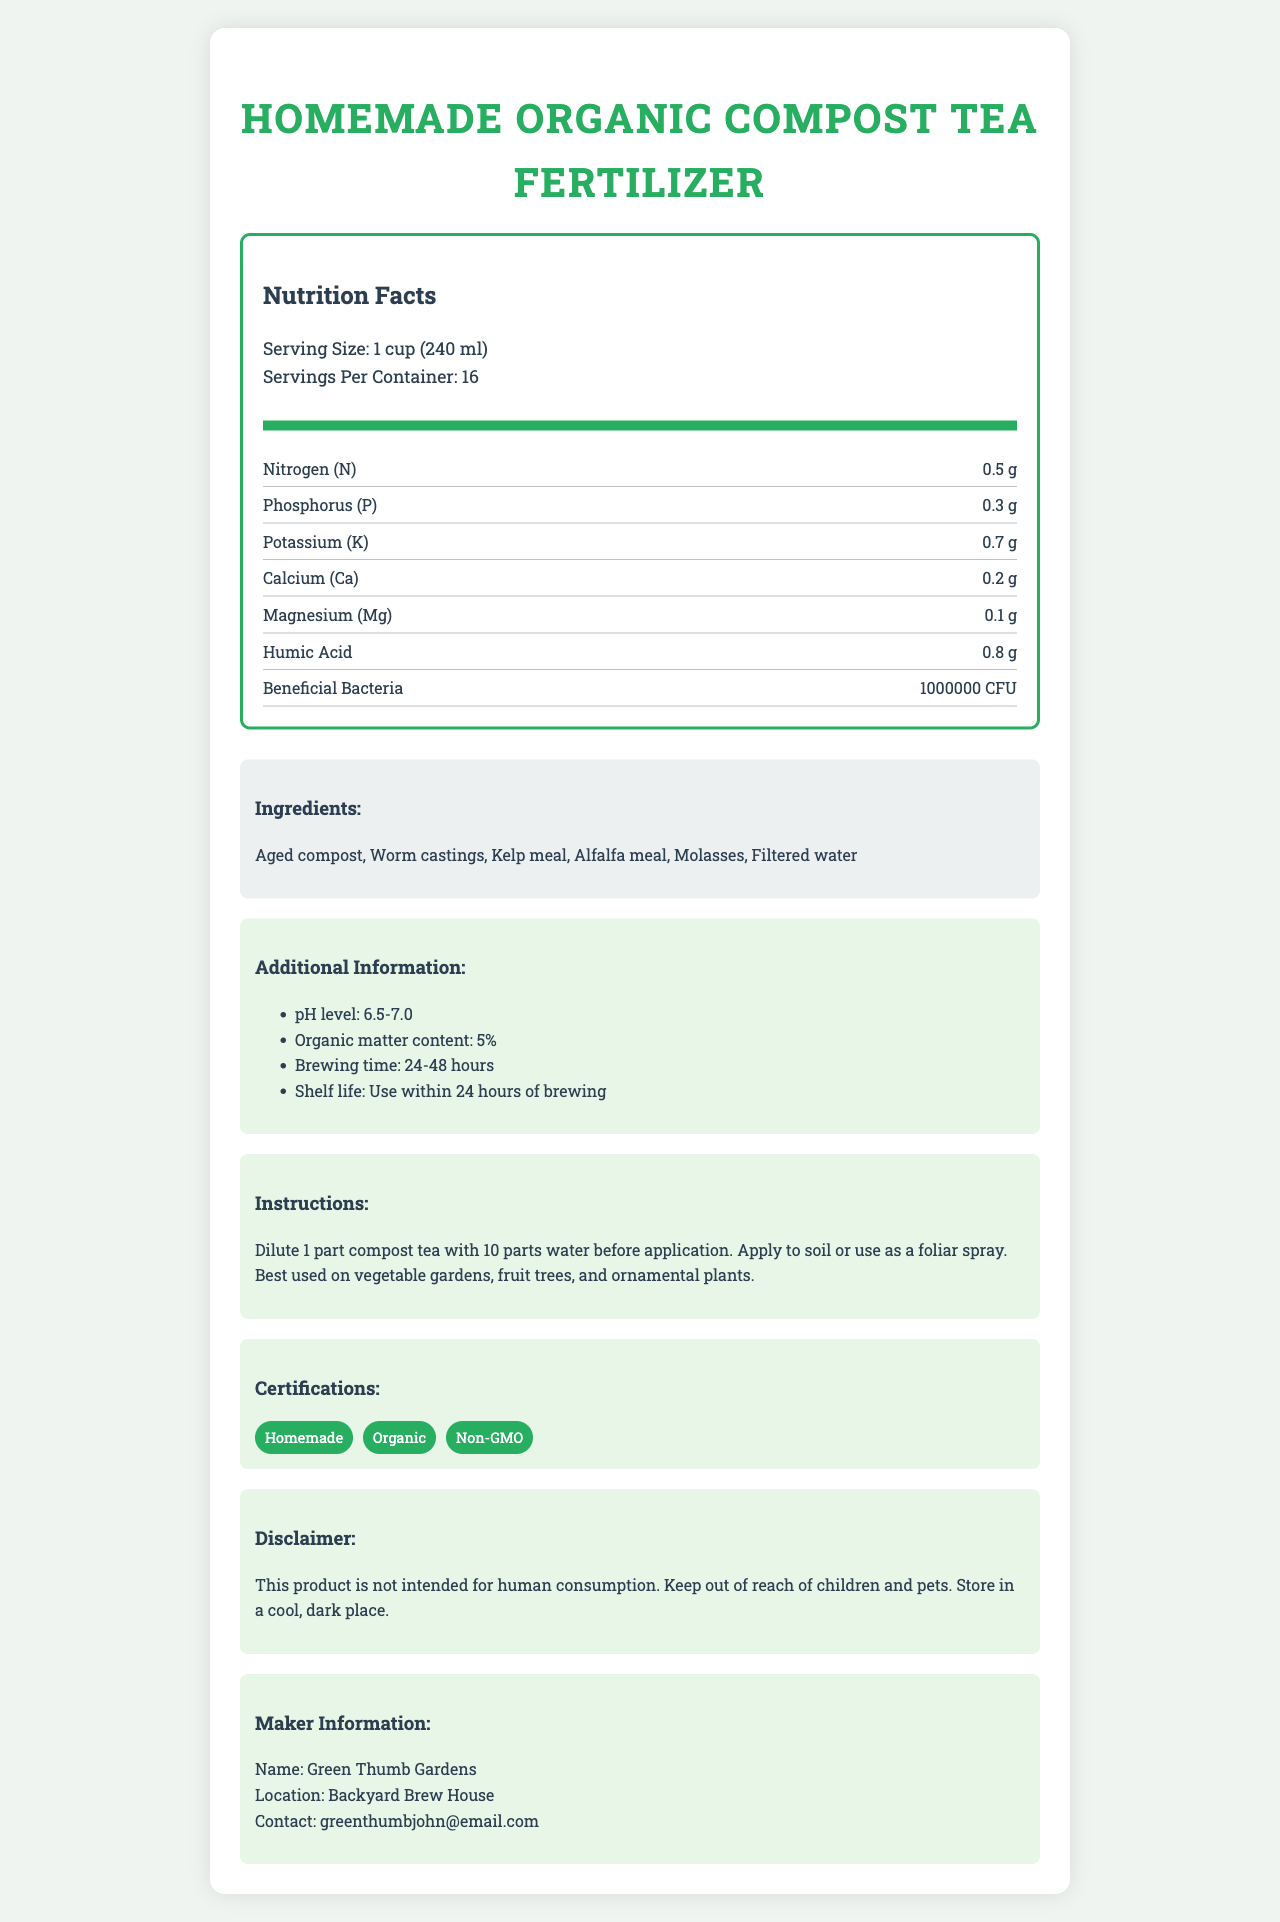what is the serving size? The serving size information is provided under the "Nutrition Facts" section of the document.
Answer: 1 cup (240 ml) how many servings are in one container? This information is listed in the "Nutrition Facts" section as "Servings Per Container."
Answer: 16 servings what certifications does the product have? The certifications are listed in the "Certifications" section, each in its own segment.
Answer: Homemade, Organic, Non-GMO which ingredient is used in the highest quantity? Filtered water is listed last in the ingredients, which usually indicates it is the primary ingredient by quantity, though this is inferred rather than explicitly stated.
Answer: Filtered water what is the pH level of the compost tea? This information is provided in the "Additional Information" section.
Answer: 6.5-7.0 what is the content percentage of organic matter? This detail is mentioned in the "Additional Information" section.
Answer: 5% how should the compost tea be applied? This instruction is detailed in the "Instructions" section.
Answer: Dilute 1 part compost tea with 10 parts water before application. Apply to soil or use as a foliar spray. what bacteria count (CFU) is present in the tea? This information is found under the nutrient named "Beneficial Bacteria" listed in the "Nutrition Facts" section.
Answer: 1,000,000 CFU which nutrient is present in the largest amount? A. Nitrogen B. Humic Acid C. Potassium Humic Acid is present in 0.8 grams per serving, which is the highest amount among listed nutrients.
Answer: B. Humic Acid how long should the tea be brewed? A. 12-24 hours B. 24-48 hours C. 48-72 hours The brewing time is specified in the "Additional Information" section.
Answer: B. 24-48 hours is the product suitable for human consumption? The disclaimer explicitly states that the product is not intended for human consumption.
Answer: No does the fertilizer contain non-organic ingredients? All listed ingredients are organic, and the product has "Organic" certification.
Answer: No summarize the main idea of the document. This summarization covers all key aspects of the document, highlighting its primary components and their significance.
Answer: The document provides detailed information on the Homemade Organic Compost Tea Fertilizer, including its nutritional content, ingredients, application instructions, certifications, and additional important details like pH level, organic content, and brewing time. what is the contact email for Green Thumb Gardens? The contact email is provided in the "Maker Information" section.
Answer: greenthumbjohn@email.com how much Magnesium is in one serving of the compost tea? This information is listed in the "Nutrition Facts" section next to the nutrient name "Magnesium (Mg)."
Answer: 0.1 g can I store the compost tea in direct sunlight? The disclaimer advises storing the product in a cool, dark place.
Answer: No what is the shelf life of the brewed tea? The "Additional Information" section clearly states the shelf life.
Answer: Use within 24 hours of brewing are there any instructions on how to dilute the compost tea? The instructions state that the tea should be diluted by mixing 1 part tea with 10 parts water before application.
Answer: Yes what is the exact amount of Nitrogen in the tea per serving? This quantity is indicated in the "Nutrition Facts" section under the nutrient name "Nitrogen (N)."
Answer: 0.5 g what is the name of the maker of the compost tea fertilizer? The "Maker Information" section provides the name of the maker.
Answer: Green Thumb Gardens how often should the compost tea be applied to the soil? The document does not specify the frequency of application for the compost tea.
Answer: Not enough information 